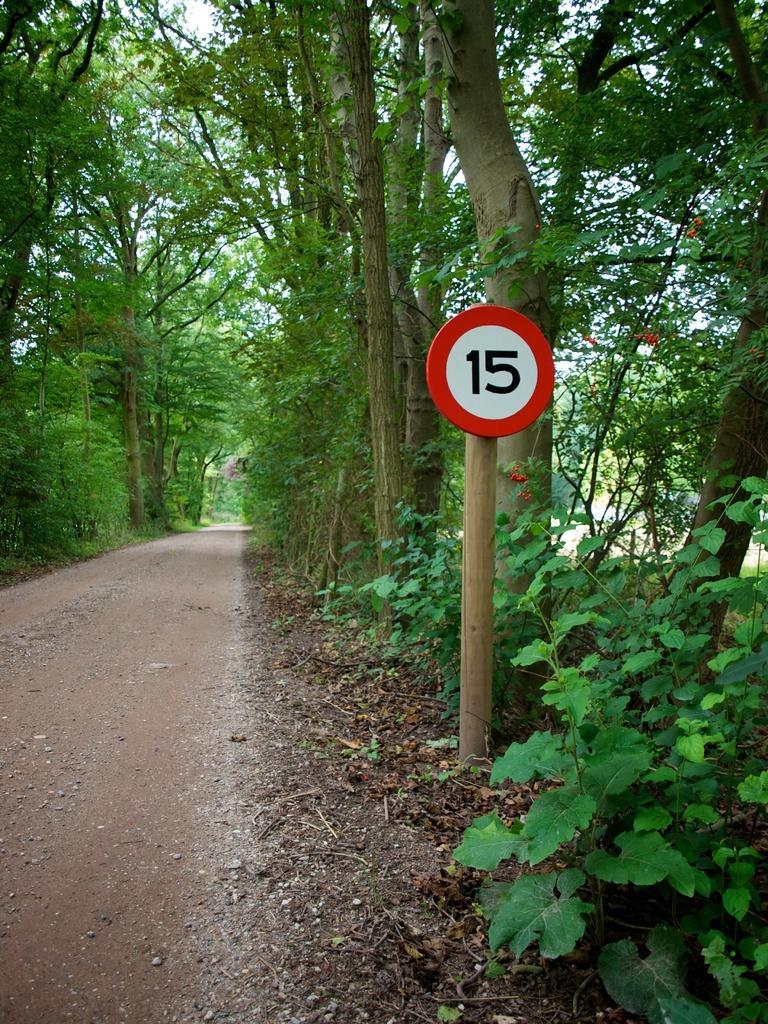Could you give a brief overview of what you see in this image? In this image we can see a road and on both sides of the road we can see many trees. Image also consists of a number pole. 